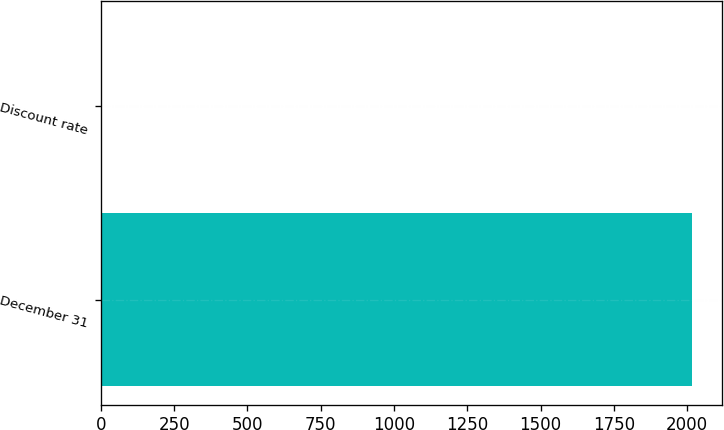Convert chart to OTSL. <chart><loc_0><loc_0><loc_500><loc_500><bar_chart><fcel>December 31<fcel>Discount rate<nl><fcel>2018<fcel>4<nl></chart> 